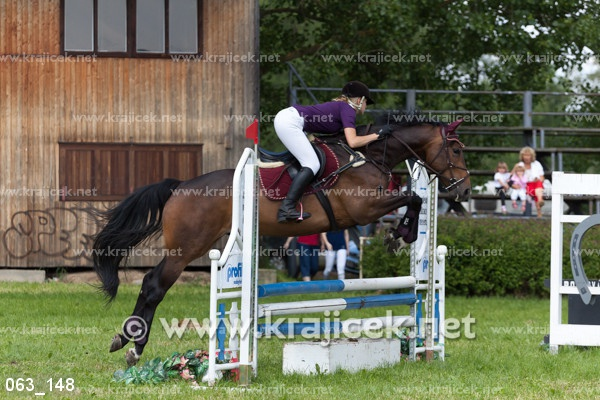Describe the objects in this image and their specific colors. I can see horse in gray, black, and maroon tones, people in gray, black, lavender, and purple tones, people in gray, lightgray, darkgray, and tan tones, people in gray, black, navy, and maroon tones, and people in gray, black, lavender, and darkgray tones in this image. 